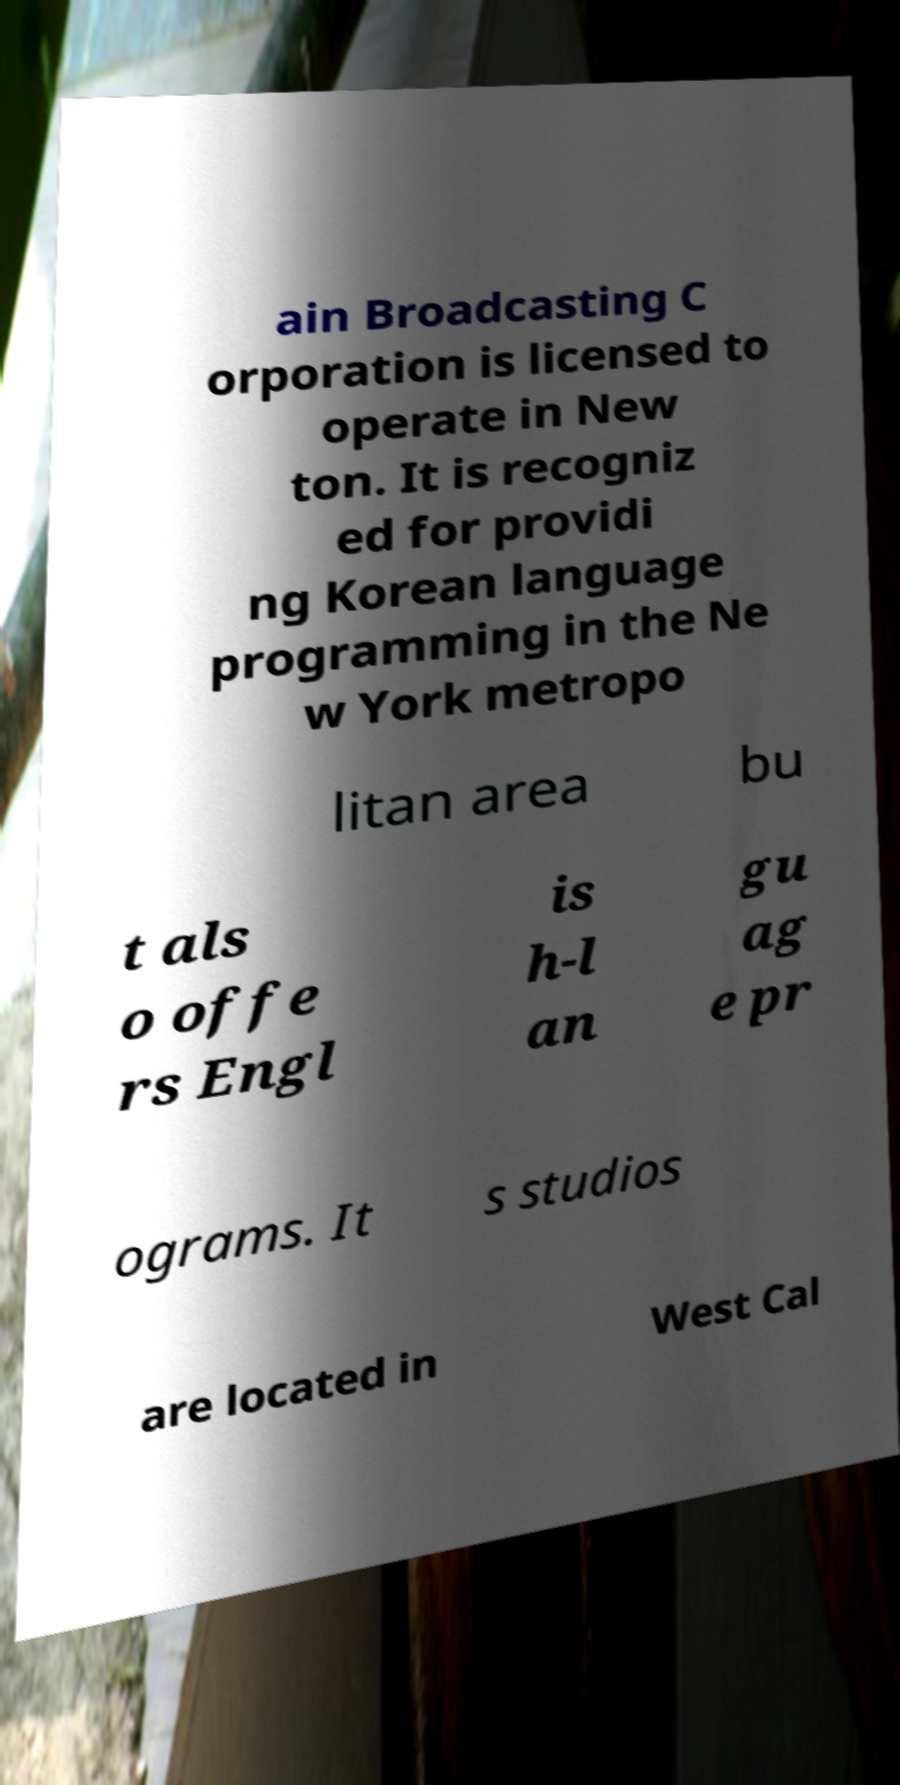What messages or text are displayed in this image? I need them in a readable, typed format. ain Broadcasting C orporation is licensed to operate in New ton. It is recogniz ed for providi ng Korean language programming in the Ne w York metropo litan area bu t als o offe rs Engl is h-l an gu ag e pr ograms. It s studios are located in West Cal 